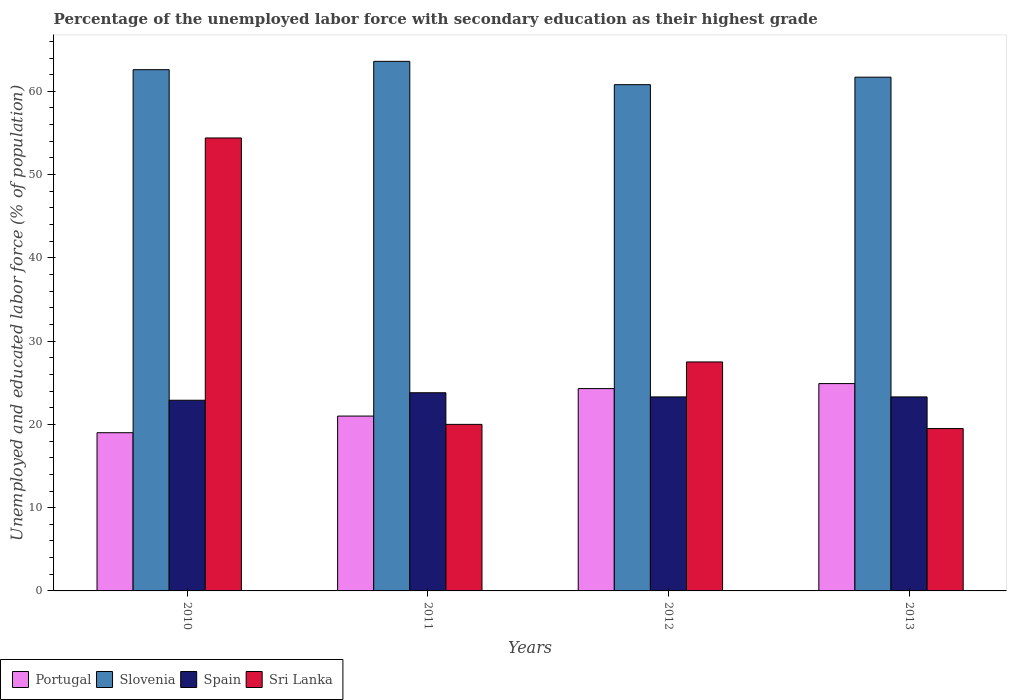How many different coloured bars are there?
Your response must be concise. 4. Are the number of bars on each tick of the X-axis equal?
Offer a terse response. Yes. In how many cases, is the number of bars for a given year not equal to the number of legend labels?
Give a very brief answer. 0. What is the percentage of the unemployed labor force with secondary education in Slovenia in 2012?
Provide a short and direct response. 60.8. Across all years, what is the maximum percentage of the unemployed labor force with secondary education in Portugal?
Your answer should be compact. 24.9. Across all years, what is the minimum percentage of the unemployed labor force with secondary education in Slovenia?
Give a very brief answer. 60.8. In which year was the percentage of the unemployed labor force with secondary education in Portugal maximum?
Provide a succinct answer. 2013. In which year was the percentage of the unemployed labor force with secondary education in Spain minimum?
Offer a very short reply. 2010. What is the total percentage of the unemployed labor force with secondary education in Slovenia in the graph?
Your response must be concise. 248.7. What is the difference between the percentage of the unemployed labor force with secondary education in Sri Lanka in 2010 and that in 2013?
Provide a short and direct response. 34.9. What is the difference between the percentage of the unemployed labor force with secondary education in Spain in 2012 and the percentage of the unemployed labor force with secondary education in Sri Lanka in 2013?
Ensure brevity in your answer.  3.8. What is the average percentage of the unemployed labor force with secondary education in Sri Lanka per year?
Give a very brief answer. 30.35. In the year 2010, what is the difference between the percentage of the unemployed labor force with secondary education in Spain and percentage of the unemployed labor force with secondary education in Portugal?
Make the answer very short. 3.9. In how many years, is the percentage of the unemployed labor force with secondary education in Sri Lanka greater than 50 %?
Keep it short and to the point. 1. What is the ratio of the percentage of the unemployed labor force with secondary education in Sri Lanka in 2011 to that in 2012?
Your answer should be very brief. 0.73. Is the percentage of the unemployed labor force with secondary education in Spain in 2010 less than that in 2013?
Ensure brevity in your answer.  Yes. Is the difference between the percentage of the unemployed labor force with secondary education in Spain in 2011 and 2013 greater than the difference between the percentage of the unemployed labor force with secondary education in Portugal in 2011 and 2013?
Offer a terse response. Yes. What is the difference between the highest and the second highest percentage of the unemployed labor force with secondary education in Sri Lanka?
Your answer should be compact. 26.9. What is the difference between the highest and the lowest percentage of the unemployed labor force with secondary education in Sri Lanka?
Offer a very short reply. 34.9. Is it the case that in every year, the sum of the percentage of the unemployed labor force with secondary education in Slovenia and percentage of the unemployed labor force with secondary education in Spain is greater than the sum of percentage of the unemployed labor force with secondary education in Portugal and percentage of the unemployed labor force with secondary education in Sri Lanka?
Your answer should be very brief. Yes. What does the 3rd bar from the left in 2011 represents?
Offer a terse response. Spain. What does the 2nd bar from the right in 2011 represents?
Your answer should be very brief. Spain. How many bars are there?
Provide a succinct answer. 16. Are all the bars in the graph horizontal?
Your answer should be compact. No. How many years are there in the graph?
Ensure brevity in your answer.  4. Does the graph contain any zero values?
Offer a terse response. No. Does the graph contain grids?
Keep it short and to the point. No. Where does the legend appear in the graph?
Your answer should be very brief. Bottom left. How many legend labels are there?
Make the answer very short. 4. What is the title of the graph?
Offer a terse response. Percentage of the unemployed labor force with secondary education as their highest grade. Does "Low & middle income" appear as one of the legend labels in the graph?
Offer a terse response. No. What is the label or title of the Y-axis?
Provide a short and direct response. Unemployed and educated labor force (% of population). What is the Unemployed and educated labor force (% of population) of Portugal in 2010?
Your answer should be very brief. 19. What is the Unemployed and educated labor force (% of population) in Slovenia in 2010?
Give a very brief answer. 62.6. What is the Unemployed and educated labor force (% of population) of Spain in 2010?
Your response must be concise. 22.9. What is the Unemployed and educated labor force (% of population) of Sri Lanka in 2010?
Your response must be concise. 54.4. What is the Unemployed and educated labor force (% of population) of Slovenia in 2011?
Your response must be concise. 63.6. What is the Unemployed and educated labor force (% of population) of Spain in 2011?
Your answer should be compact. 23.8. What is the Unemployed and educated labor force (% of population) of Sri Lanka in 2011?
Give a very brief answer. 20. What is the Unemployed and educated labor force (% of population) of Portugal in 2012?
Your answer should be compact. 24.3. What is the Unemployed and educated labor force (% of population) in Slovenia in 2012?
Offer a terse response. 60.8. What is the Unemployed and educated labor force (% of population) of Spain in 2012?
Ensure brevity in your answer.  23.3. What is the Unemployed and educated labor force (% of population) in Sri Lanka in 2012?
Your answer should be very brief. 27.5. What is the Unemployed and educated labor force (% of population) of Portugal in 2013?
Provide a succinct answer. 24.9. What is the Unemployed and educated labor force (% of population) in Slovenia in 2013?
Keep it short and to the point. 61.7. What is the Unemployed and educated labor force (% of population) in Spain in 2013?
Ensure brevity in your answer.  23.3. Across all years, what is the maximum Unemployed and educated labor force (% of population) in Portugal?
Provide a short and direct response. 24.9. Across all years, what is the maximum Unemployed and educated labor force (% of population) of Slovenia?
Ensure brevity in your answer.  63.6. Across all years, what is the maximum Unemployed and educated labor force (% of population) of Spain?
Offer a very short reply. 23.8. Across all years, what is the maximum Unemployed and educated labor force (% of population) in Sri Lanka?
Keep it short and to the point. 54.4. Across all years, what is the minimum Unemployed and educated labor force (% of population) of Slovenia?
Make the answer very short. 60.8. Across all years, what is the minimum Unemployed and educated labor force (% of population) of Spain?
Give a very brief answer. 22.9. Across all years, what is the minimum Unemployed and educated labor force (% of population) in Sri Lanka?
Give a very brief answer. 19.5. What is the total Unemployed and educated labor force (% of population) in Portugal in the graph?
Ensure brevity in your answer.  89.2. What is the total Unemployed and educated labor force (% of population) of Slovenia in the graph?
Make the answer very short. 248.7. What is the total Unemployed and educated labor force (% of population) of Spain in the graph?
Provide a succinct answer. 93.3. What is the total Unemployed and educated labor force (% of population) in Sri Lanka in the graph?
Ensure brevity in your answer.  121.4. What is the difference between the Unemployed and educated labor force (% of population) in Portugal in 2010 and that in 2011?
Ensure brevity in your answer.  -2. What is the difference between the Unemployed and educated labor force (% of population) of Slovenia in 2010 and that in 2011?
Keep it short and to the point. -1. What is the difference between the Unemployed and educated labor force (% of population) of Spain in 2010 and that in 2011?
Offer a terse response. -0.9. What is the difference between the Unemployed and educated labor force (% of population) of Sri Lanka in 2010 and that in 2011?
Your answer should be very brief. 34.4. What is the difference between the Unemployed and educated labor force (% of population) in Portugal in 2010 and that in 2012?
Provide a succinct answer. -5.3. What is the difference between the Unemployed and educated labor force (% of population) in Slovenia in 2010 and that in 2012?
Give a very brief answer. 1.8. What is the difference between the Unemployed and educated labor force (% of population) of Sri Lanka in 2010 and that in 2012?
Ensure brevity in your answer.  26.9. What is the difference between the Unemployed and educated labor force (% of population) of Portugal in 2010 and that in 2013?
Your answer should be very brief. -5.9. What is the difference between the Unemployed and educated labor force (% of population) of Sri Lanka in 2010 and that in 2013?
Provide a short and direct response. 34.9. What is the difference between the Unemployed and educated labor force (% of population) of Portugal in 2011 and that in 2012?
Keep it short and to the point. -3.3. What is the difference between the Unemployed and educated labor force (% of population) of Slovenia in 2011 and that in 2012?
Your answer should be very brief. 2.8. What is the difference between the Unemployed and educated labor force (% of population) of Sri Lanka in 2011 and that in 2012?
Give a very brief answer. -7.5. What is the difference between the Unemployed and educated labor force (% of population) of Slovenia in 2011 and that in 2013?
Give a very brief answer. 1.9. What is the difference between the Unemployed and educated labor force (% of population) in Portugal in 2012 and that in 2013?
Your answer should be compact. -0.6. What is the difference between the Unemployed and educated labor force (% of population) in Spain in 2012 and that in 2013?
Offer a terse response. 0. What is the difference between the Unemployed and educated labor force (% of population) of Portugal in 2010 and the Unemployed and educated labor force (% of population) of Slovenia in 2011?
Keep it short and to the point. -44.6. What is the difference between the Unemployed and educated labor force (% of population) of Portugal in 2010 and the Unemployed and educated labor force (% of population) of Sri Lanka in 2011?
Provide a succinct answer. -1. What is the difference between the Unemployed and educated labor force (% of population) of Slovenia in 2010 and the Unemployed and educated labor force (% of population) of Spain in 2011?
Offer a terse response. 38.8. What is the difference between the Unemployed and educated labor force (% of population) in Slovenia in 2010 and the Unemployed and educated labor force (% of population) in Sri Lanka in 2011?
Give a very brief answer. 42.6. What is the difference between the Unemployed and educated labor force (% of population) of Spain in 2010 and the Unemployed and educated labor force (% of population) of Sri Lanka in 2011?
Your answer should be compact. 2.9. What is the difference between the Unemployed and educated labor force (% of population) of Portugal in 2010 and the Unemployed and educated labor force (% of population) of Slovenia in 2012?
Ensure brevity in your answer.  -41.8. What is the difference between the Unemployed and educated labor force (% of population) of Portugal in 2010 and the Unemployed and educated labor force (% of population) of Spain in 2012?
Give a very brief answer. -4.3. What is the difference between the Unemployed and educated labor force (% of population) of Slovenia in 2010 and the Unemployed and educated labor force (% of population) of Spain in 2012?
Keep it short and to the point. 39.3. What is the difference between the Unemployed and educated labor force (% of population) of Slovenia in 2010 and the Unemployed and educated labor force (% of population) of Sri Lanka in 2012?
Ensure brevity in your answer.  35.1. What is the difference between the Unemployed and educated labor force (% of population) in Spain in 2010 and the Unemployed and educated labor force (% of population) in Sri Lanka in 2012?
Offer a very short reply. -4.6. What is the difference between the Unemployed and educated labor force (% of population) in Portugal in 2010 and the Unemployed and educated labor force (% of population) in Slovenia in 2013?
Offer a terse response. -42.7. What is the difference between the Unemployed and educated labor force (% of population) of Portugal in 2010 and the Unemployed and educated labor force (% of population) of Spain in 2013?
Make the answer very short. -4.3. What is the difference between the Unemployed and educated labor force (% of population) in Portugal in 2010 and the Unemployed and educated labor force (% of population) in Sri Lanka in 2013?
Your answer should be very brief. -0.5. What is the difference between the Unemployed and educated labor force (% of population) of Slovenia in 2010 and the Unemployed and educated labor force (% of population) of Spain in 2013?
Your response must be concise. 39.3. What is the difference between the Unemployed and educated labor force (% of population) of Slovenia in 2010 and the Unemployed and educated labor force (% of population) of Sri Lanka in 2013?
Provide a short and direct response. 43.1. What is the difference between the Unemployed and educated labor force (% of population) in Portugal in 2011 and the Unemployed and educated labor force (% of population) in Slovenia in 2012?
Provide a short and direct response. -39.8. What is the difference between the Unemployed and educated labor force (% of population) of Portugal in 2011 and the Unemployed and educated labor force (% of population) of Spain in 2012?
Keep it short and to the point. -2.3. What is the difference between the Unemployed and educated labor force (% of population) of Portugal in 2011 and the Unemployed and educated labor force (% of population) of Sri Lanka in 2012?
Offer a very short reply. -6.5. What is the difference between the Unemployed and educated labor force (% of population) in Slovenia in 2011 and the Unemployed and educated labor force (% of population) in Spain in 2012?
Offer a terse response. 40.3. What is the difference between the Unemployed and educated labor force (% of population) of Slovenia in 2011 and the Unemployed and educated labor force (% of population) of Sri Lanka in 2012?
Make the answer very short. 36.1. What is the difference between the Unemployed and educated labor force (% of population) in Spain in 2011 and the Unemployed and educated labor force (% of population) in Sri Lanka in 2012?
Make the answer very short. -3.7. What is the difference between the Unemployed and educated labor force (% of population) in Portugal in 2011 and the Unemployed and educated labor force (% of population) in Slovenia in 2013?
Keep it short and to the point. -40.7. What is the difference between the Unemployed and educated labor force (% of population) of Portugal in 2011 and the Unemployed and educated labor force (% of population) of Sri Lanka in 2013?
Provide a short and direct response. 1.5. What is the difference between the Unemployed and educated labor force (% of population) in Slovenia in 2011 and the Unemployed and educated labor force (% of population) in Spain in 2013?
Keep it short and to the point. 40.3. What is the difference between the Unemployed and educated labor force (% of population) of Slovenia in 2011 and the Unemployed and educated labor force (% of population) of Sri Lanka in 2013?
Provide a short and direct response. 44.1. What is the difference between the Unemployed and educated labor force (% of population) in Portugal in 2012 and the Unemployed and educated labor force (% of population) in Slovenia in 2013?
Provide a succinct answer. -37.4. What is the difference between the Unemployed and educated labor force (% of population) of Portugal in 2012 and the Unemployed and educated labor force (% of population) of Spain in 2013?
Offer a very short reply. 1. What is the difference between the Unemployed and educated labor force (% of population) of Slovenia in 2012 and the Unemployed and educated labor force (% of population) of Spain in 2013?
Provide a short and direct response. 37.5. What is the difference between the Unemployed and educated labor force (% of population) in Slovenia in 2012 and the Unemployed and educated labor force (% of population) in Sri Lanka in 2013?
Provide a succinct answer. 41.3. What is the average Unemployed and educated labor force (% of population) of Portugal per year?
Offer a very short reply. 22.3. What is the average Unemployed and educated labor force (% of population) in Slovenia per year?
Make the answer very short. 62.17. What is the average Unemployed and educated labor force (% of population) in Spain per year?
Ensure brevity in your answer.  23.32. What is the average Unemployed and educated labor force (% of population) of Sri Lanka per year?
Your answer should be very brief. 30.35. In the year 2010, what is the difference between the Unemployed and educated labor force (% of population) in Portugal and Unemployed and educated labor force (% of population) in Slovenia?
Keep it short and to the point. -43.6. In the year 2010, what is the difference between the Unemployed and educated labor force (% of population) in Portugal and Unemployed and educated labor force (% of population) in Sri Lanka?
Give a very brief answer. -35.4. In the year 2010, what is the difference between the Unemployed and educated labor force (% of population) of Slovenia and Unemployed and educated labor force (% of population) of Spain?
Your response must be concise. 39.7. In the year 2010, what is the difference between the Unemployed and educated labor force (% of population) of Slovenia and Unemployed and educated labor force (% of population) of Sri Lanka?
Provide a succinct answer. 8.2. In the year 2010, what is the difference between the Unemployed and educated labor force (% of population) of Spain and Unemployed and educated labor force (% of population) of Sri Lanka?
Your response must be concise. -31.5. In the year 2011, what is the difference between the Unemployed and educated labor force (% of population) in Portugal and Unemployed and educated labor force (% of population) in Slovenia?
Keep it short and to the point. -42.6. In the year 2011, what is the difference between the Unemployed and educated labor force (% of population) of Slovenia and Unemployed and educated labor force (% of population) of Spain?
Make the answer very short. 39.8. In the year 2011, what is the difference between the Unemployed and educated labor force (% of population) in Slovenia and Unemployed and educated labor force (% of population) in Sri Lanka?
Your answer should be very brief. 43.6. In the year 2011, what is the difference between the Unemployed and educated labor force (% of population) in Spain and Unemployed and educated labor force (% of population) in Sri Lanka?
Your answer should be compact. 3.8. In the year 2012, what is the difference between the Unemployed and educated labor force (% of population) of Portugal and Unemployed and educated labor force (% of population) of Slovenia?
Offer a very short reply. -36.5. In the year 2012, what is the difference between the Unemployed and educated labor force (% of population) in Portugal and Unemployed and educated labor force (% of population) in Spain?
Your answer should be compact. 1. In the year 2012, what is the difference between the Unemployed and educated labor force (% of population) of Slovenia and Unemployed and educated labor force (% of population) of Spain?
Ensure brevity in your answer.  37.5. In the year 2012, what is the difference between the Unemployed and educated labor force (% of population) in Slovenia and Unemployed and educated labor force (% of population) in Sri Lanka?
Provide a short and direct response. 33.3. In the year 2012, what is the difference between the Unemployed and educated labor force (% of population) of Spain and Unemployed and educated labor force (% of population) of Sri Lanka?
Give a very brief answer. -4.2. In the year 2013, what is the difference between the Unemployed and educated labor force (% of population) in Portugal and Unemployed and educated labor force (% of population) in Slovenia?
Your answer should be very brief. -36.8. In the year 2013, what is the difference between the Unemployed and educated labor force (% of population) of Portugal and Unemployed and educated labor force (% of population) of Spain?
Your answer should be very brief. 1.6. In the year 2013, what is the difference between the Unemployed and educated labor force (% of population) of Portugal and Unemployed and educated labor force (% of population) of Sri Lanka?
Your answer should be compact. 5.4. In the year 2013, what is the difference between the Unemployed and educated labor force (% of population) in Slovenia and Unemployed and educated labor force (% of population) in Spain?
Provide a succinct answer. 38.4. In the year 2013, what is the difference between the Unemployed and educated labor force (% of population) in Slovenia and Unemployed and educated labor force (% of population) in Sri Lanka?
Your answer should be compact. 42.2. In the year 2013, what is the difference between the Unemployed and educated labor force (% of population) of Spain and Unemployed and educated labor force (% of population) of Sri Lanka?
Make the answer very short. 3.8. What is the ratio of the Unemployed and educated labor force (% of population) in Portugal in 2010 to that in 2011?
Offer a terse response. 0.9. What is the ratio of the Unemployed and educated labor force (% of population) in Slovenia in 2010 to that in 2011?
Your answer should be very brief. 0.98. What is the ratio of the Unemployed and educated labor force (% of population) in Spain in 2010 to that in 2011?
Your answer should be compact. 0.96. What is the ratio of the Unemployed and educated labor force (% of population) of Sri Lanka in 2010 to that in 2011?
Keep it short and to the point. 2.72. What is the ratio of the Unemployed and educated labor force (% of population) of Portugal in 2010 to that in 2012?
Keep it short and to the point. 0.78. What is the ratio of the Unemployed and educated labor force (% of population) of Slovenia in 2010 to that in 2012?
Give a very brief answer. 1.03. What is the ratio of the Unemployed and educated labor force (% of population) of Spain in 2010 to that in 2012?
Give a very brief answer. 0.98. What is the ratio of the Unemployed and educated labor force (% of population) in Sri Lanka in 2010 to that in 2012?
Offer a very short reply. 1.98. What is the ratio of the Unemployed and educated labor force (% of population) of Portugal in 2010 to that in 2013?
Provide a short and direct response. 0.76. What is the ratio of the Unemployed and educated labor force (% of population) in Slovenia in 2010 to that in 2013?
Ensure brevity in your answer.  1.01. What is the ratio of the Unemployed and educated labor force (% of population) in Spain in 2010 to that in 2013?
Ensure brevity in your answer.  0.98. What is the ratio of the Unemployed and educated labor force (% of population) in Sri Lanka in 2010 to that in 2013?
Give a very brief answer. 2.79. What is the ratio of the Unemployed and educated labor force (% of population) of Portugal in 2011 to that in 2012?
Provide a short and direct response. 0.86. What is the ratio of the Unemployed and educated labor force (% of population) of Slovenia in 2011 to that in 2012?
Offer a terse response. 1.05. What is the ratio of the Unemployed and educated labor force (% of population) of Spain in 2011 to that in 2012?
Provide a succinct answer. 1.02. What is the ratio of the Unemployed and educated labor force (% of population) in Sri Lanka in 2011 to that in 2012?
Make the answer very short. 0.73. What is the ratio of the Unemployed and educated labor force (% of population) in Portugal in 2011 to that in 2013?
Your answer should be very brief. 0.84. What is the ratio of the Unemployed and educated labor force (% of population) in Slovenia in 2011 to that in 2013?
Provide a succinct answer. 1.03. What is the ratio of the Unemployed and educated labor force (% of population) in Spain in 2011 to that in 2013?
Provide a succinct answer. 1.02. What is the ratio of the Unemployed and educated labor force (% of population) of Sri Lanka in 2011 to that in 2013?
Offer a very short reply. 1.03. What is the ratio of the Unemployed and educated labor force (% of population) in Portugal in 2012 to that in 2013?
Provide a succinct answer. 0.98. What is the ratio of the Unemployed and educated labor force (% of population) in Slovenia in 2012 to that in 2013?
Offer a very short reply. 0.99. What is the ratio of the Unemployed and educated labor force (% of population) of Spain in 2012 to that in 2013?
Ensure brevity in your answer.  1. What is the ratio of the Unemployed and educated labor force (% of population) of Sri Lanka in 2012 to that in 2013?
Offer a very short reply. 1.41. What is the difference between the highest and the second highest Unemployed and educated labor force (% of population) of Sri Lanka?
Provide a succinct answer. 26.9. What is the difference between the highest and the lowest Unemployed and educated labor force (% of population) in Slovenia?
Offer a very short reply. 2.8. What is the difference between the highest and the lowest Unemployed and educated labor force (% of population) of Spain?
Ensure brevity in your answer.  0.9. What is the difference between the highest and the lowest Unemployed and educated labor force (% of population) in Sri Lanka?
Give a very brief answer. 34.9. 